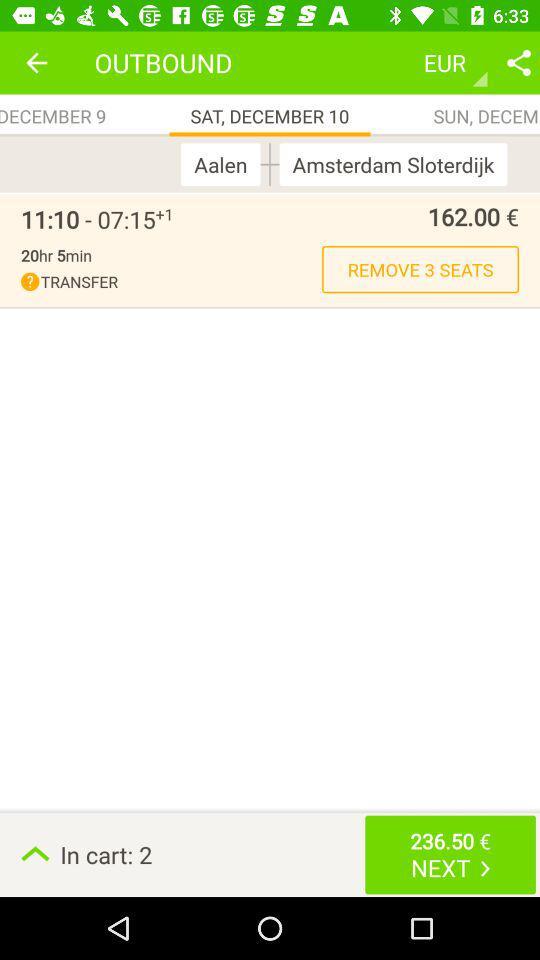How many seats are there in the "REMOVE" option? There are 3 seats. 